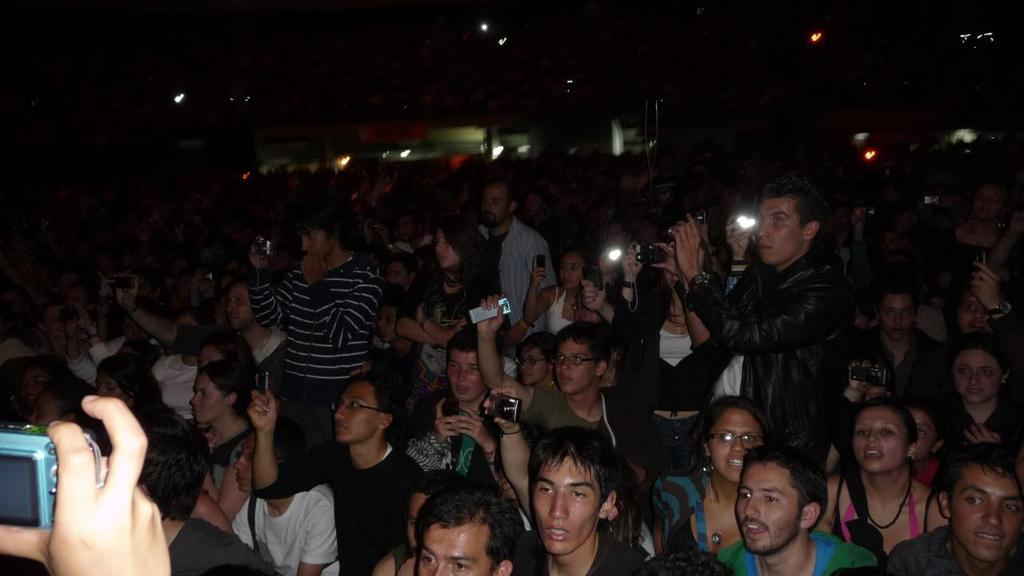What are the people in the image holding? The people in the image are holding cameras and mobile phones. What are the people doing with the cameras and mobile phones? The people are shooting something. Can you describe the background of the image? There are spectators in the background of the image. What type of guitar can be seen being played by a snake in the image? There is no guitar or snake present in the image. 